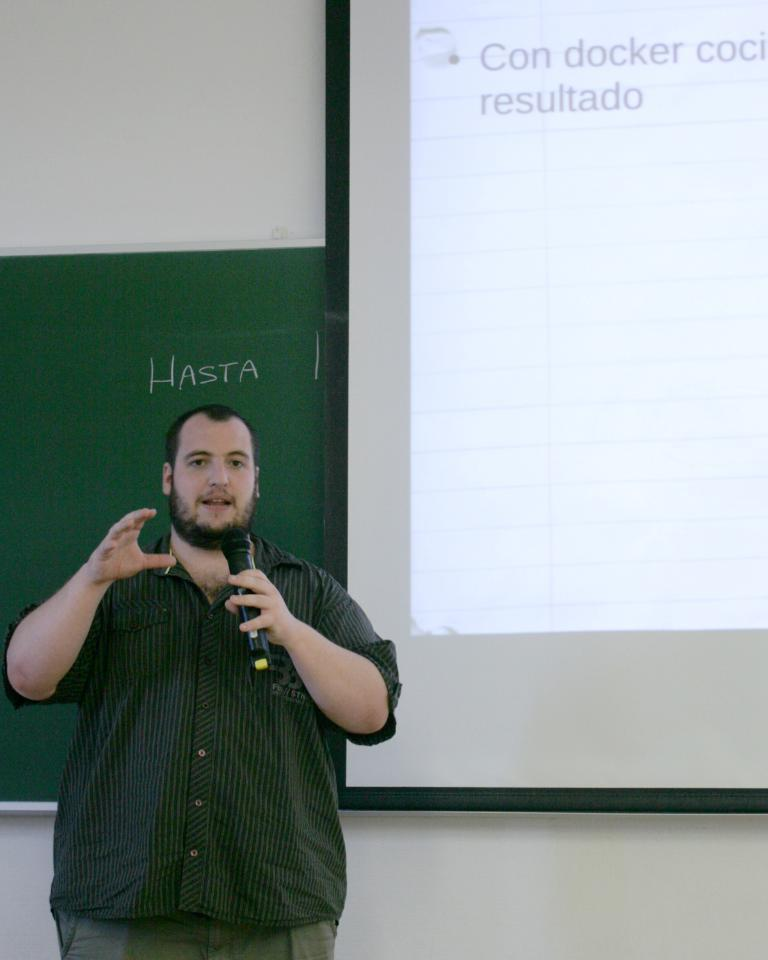What is the person in the image doing? The person is standing and holding a microphone. What object can be seen in the person's hand? The person is holding a microphone. What is the green object in the image? There is a green board in the image. What is being displayed at the back of the room? There is a projector display at the back. How many grapes are on the person's head in the image? There are no grapes present in the image, so it is not possible to determine how many grapes might be on the person's head. 